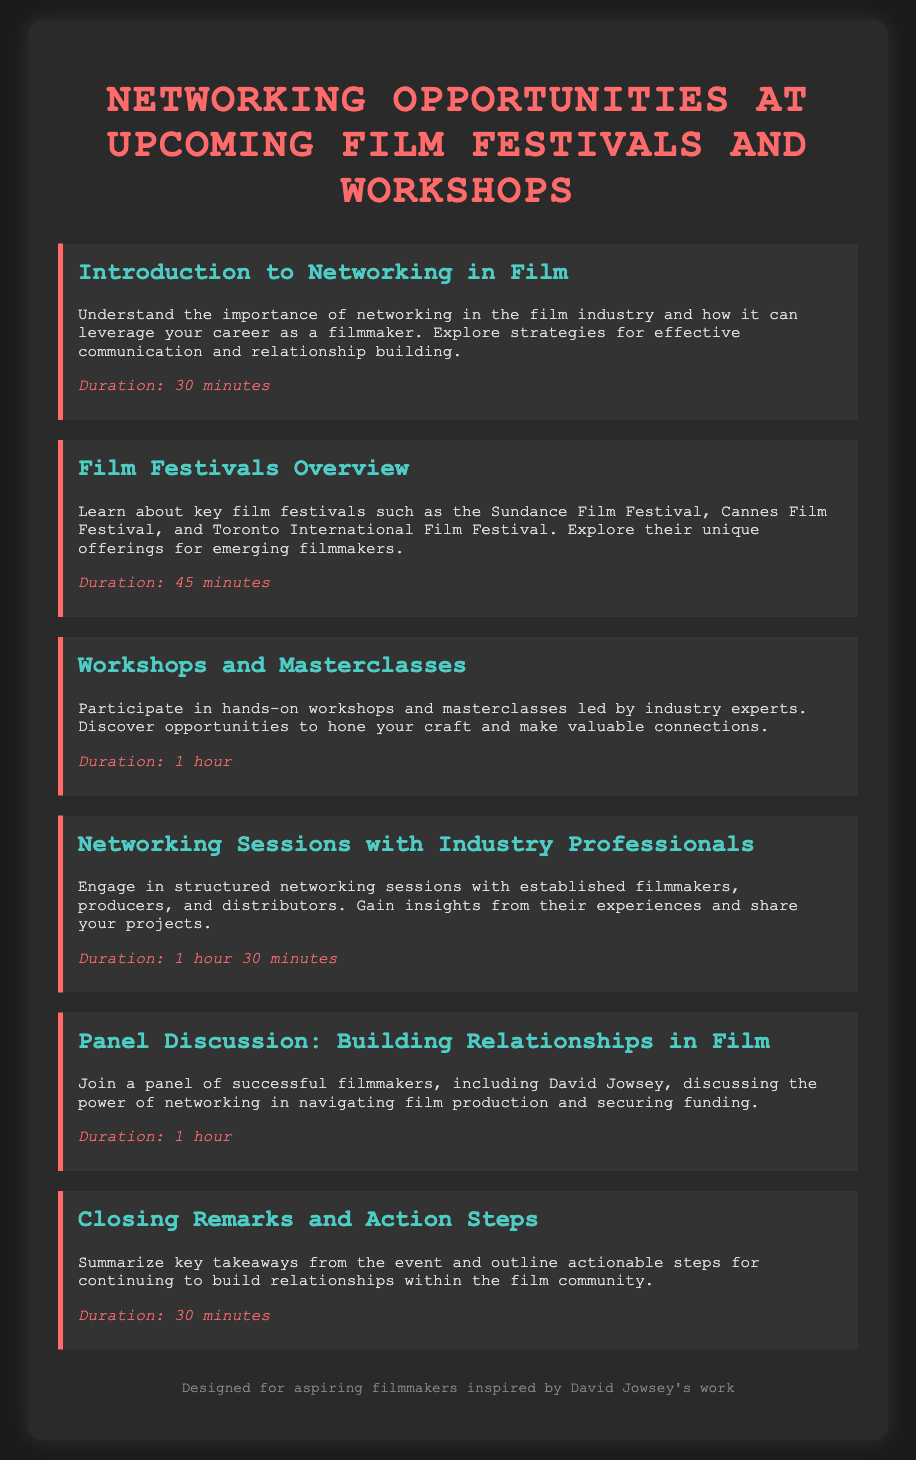What is the title of the document? The title of the document is prominently displayed at the top, indicating the main focus of the content.
Answer: Networking Opportunities at Upcoming Film Festivals and Workshops What is the duration of the "Workshops and Masterclasses" section? Each agenda item includes a specific duration, which for this section is mentioned clearly at the end of the description.
Answer: 1 hour Who is included in the panel discussion? The panel discussion section mentions specific individuals contributing to the conversation about networking in film.
Answer: David Jowsey How long is the "Networking Sessions with Industry Professionals"? The duration for this particular networking session is specified within the structured agenda format.
Answer: 1 hour 30 minutes What is the focus of the "Introduction to Networking in Film"? The description of this agenda item outlines its main purpose in terms of understanding networking in the film industry.
Answer: Importance of networking What is summarized in the "Closing Remarks and Action Steps"? The agenda item details what will be summarized at the end of the event, focusing on the takeaways.
Answer: Key takeaways What does the "Film Festivals Overview" item cover? This section provides insight into significant film festivals and their relevance to emerging filmmakers.
Answer: Key film festivals What type of professionals participate in the structured networking sessions? The description specifies the kinds of industry experts involved in the networking opportunities presented.
Answer: Filmmakers, producers, distributors What color is used for the header of the agenda items? The style is specified in the document, indicating the color used for this important structural feature.
Answer: #4ecdc4 